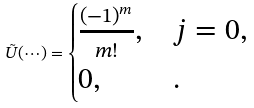Convert formula to latex. <formula><loc_0><loc_0><loc_500><loc_500>\tilde { U } ( { \cdots } ) = \begin{cases} \frac { ( - 1 ) ^ { m } } { m ! } , & j = 0 , \\ 0 , & . \end{cases}</formula> 